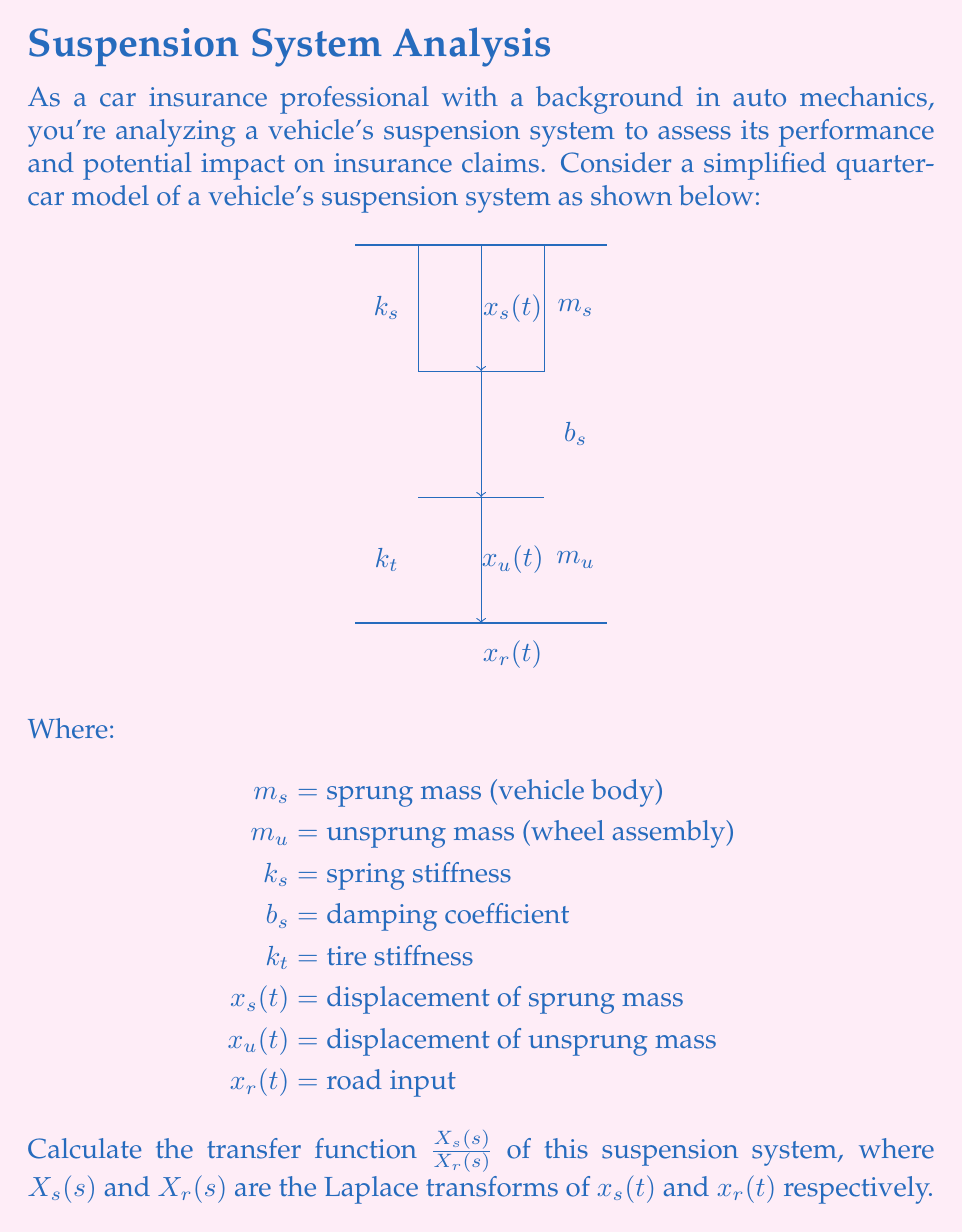Provide a solution to this math problem. Let's approach this step-by-step:

1) First, we need to write the equations of motion for both masses:

   For $m_s$: $m_s\ddot{x}_s = -k_s(x_s - x_u) - b_s(\dot{x}_s - \dot{x}_u)$
   For $m_u$: $m_u\ddot{x}_u = k_s(x_s - x_u) + b_s(\dot{x}_s - \dot{x}_u) - k_t(x_u - x_r)$

2) Now, we take the Laplace transform of both equations, assuming zero initial conditions:

   $m_s s^2 X_s(s) = -k_s(X_s(s) - X_u(s)) - b_s s(X_s(s) - X_u(s))$
   $m_u s^2 X_u(s) = k_s(X_s(s) - X_u(s)) + b_s s(X_s(s) - X_u(s)) - k_t(X_u(s) - X_r(s))$

3) Rearrange these equations:

   $(m_s s^2 + b_s s + k_s)X_s(s) = (b_s s + k_s)X_u(s)$
   $(m_u s^2 + b_s s + k_s + k_t)X_u(s) = (b_s s + k_s)X_s(s) + k_t X_r(s)$

4) From the first equation:

   $X_u(s) = \frac{m_s s^2 + b_s s + k_s}{b_s s + k_s}X_s(s)$

5) Substitute this into the second equation:

   $(m_u s^2 + b_s s + k_s + k_t)\frac{m_s s^2 + b_s s + k_s}{b_s s + k_s}X_s(s) = (b_s s + k_s)X_s(s) + k_t X_r(s)$

6) Simplify and rearrange to get $\frac{X_s(s)}{X_r(s)}$:

   $\frac{X_s(s)}{X_r(s)} = \frac{k_t(b_s s + k_s)}{(m_s s^2 + b_s s + k_s)(m_u s^2 + b_s s + k_s + k_t) - (b_s s + k_s)^2}$

This is the transfer function of the suspension system.
Answer: $$\frac{X_s(s)}{X_r(s)} = \frac{k_t(b_s s + k_s)}{(m_s s^2 + b_s s + k_s)(m_u s^2 + b_s s + k_s + k_t) - (b_s s + k_s)^2}$$ 